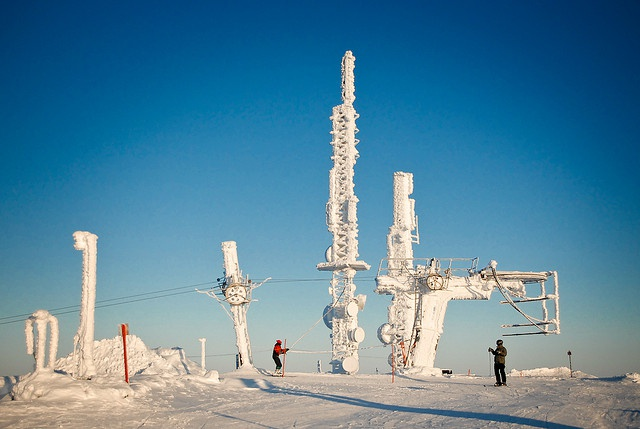Describe the objects in this image and their specific colors. I can see people in navy, black, maroon, and gray tones, people in navy, black, red, brown, and maroon tones, and skis in navy, gray, and black tones in this image. 